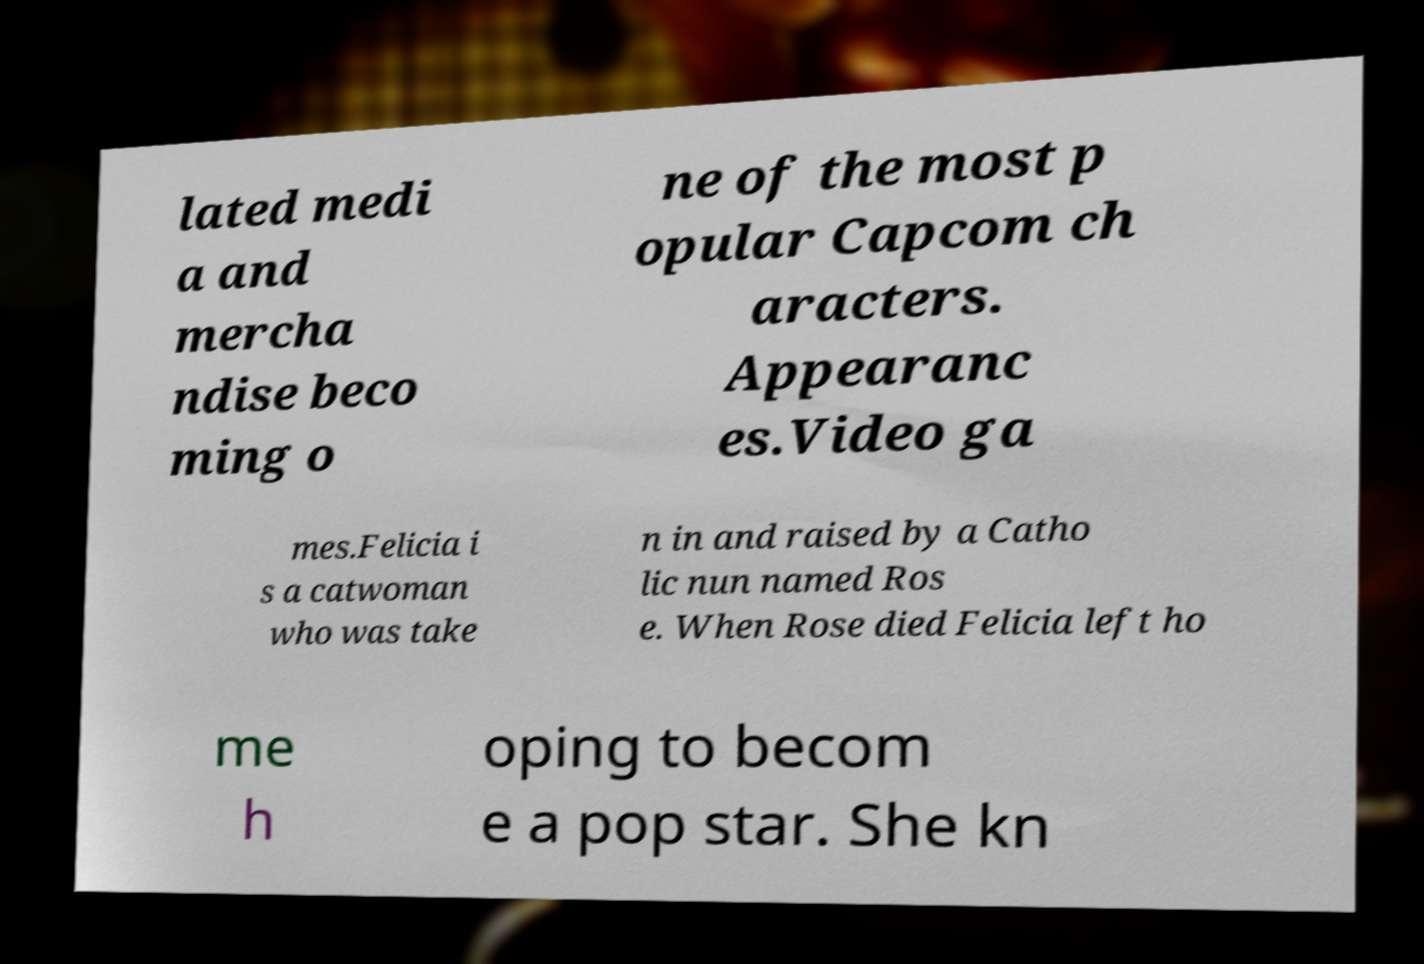Could you assist in decoding the text presented in this image and type it out clearly? lated medi a and mercha ndise beco ming o ne of the most p opular Capcom ch aracters. Appearanc es.Video ga mes.Felicia i s a catwoman who was take n in and raised by a Catho lic nun named Ros e. When Rose died Felicia left ho me h oping to becom e a pop star. She kn 